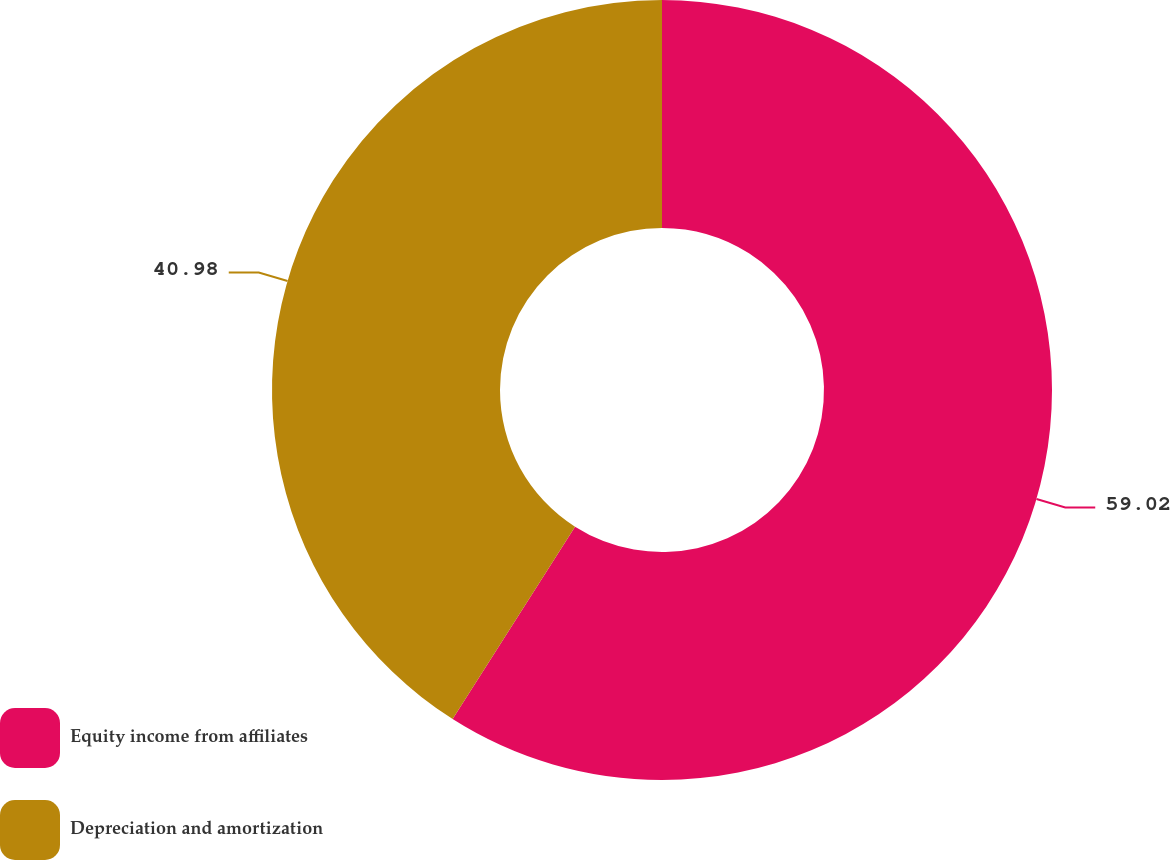Convert chart to OTSL. <chart><loc_0><loc_0><loc_500><loc_500><pie_chart><fcel>Equity income from affiliates<fcel>Depreciation and amortization<nl><fcel>59.02%<fcel>40.98%<nl></chart> 